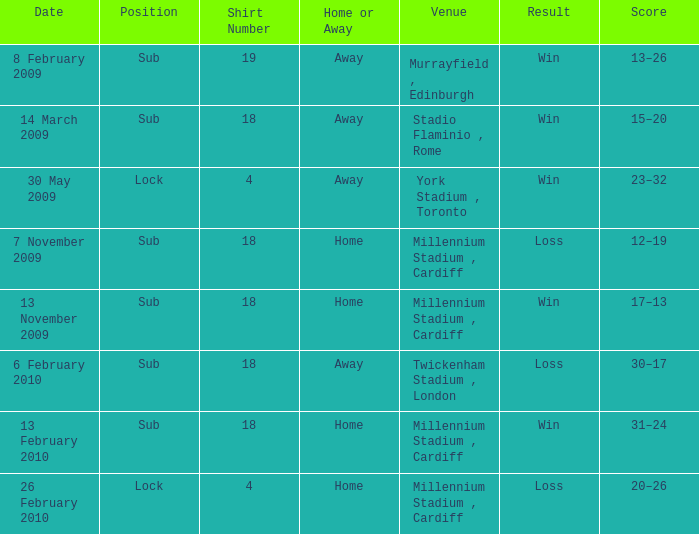Can you tell me the lowest Cap Number that has the Date of 8 february 2009, and the Shirt Number larger than 19? None. 